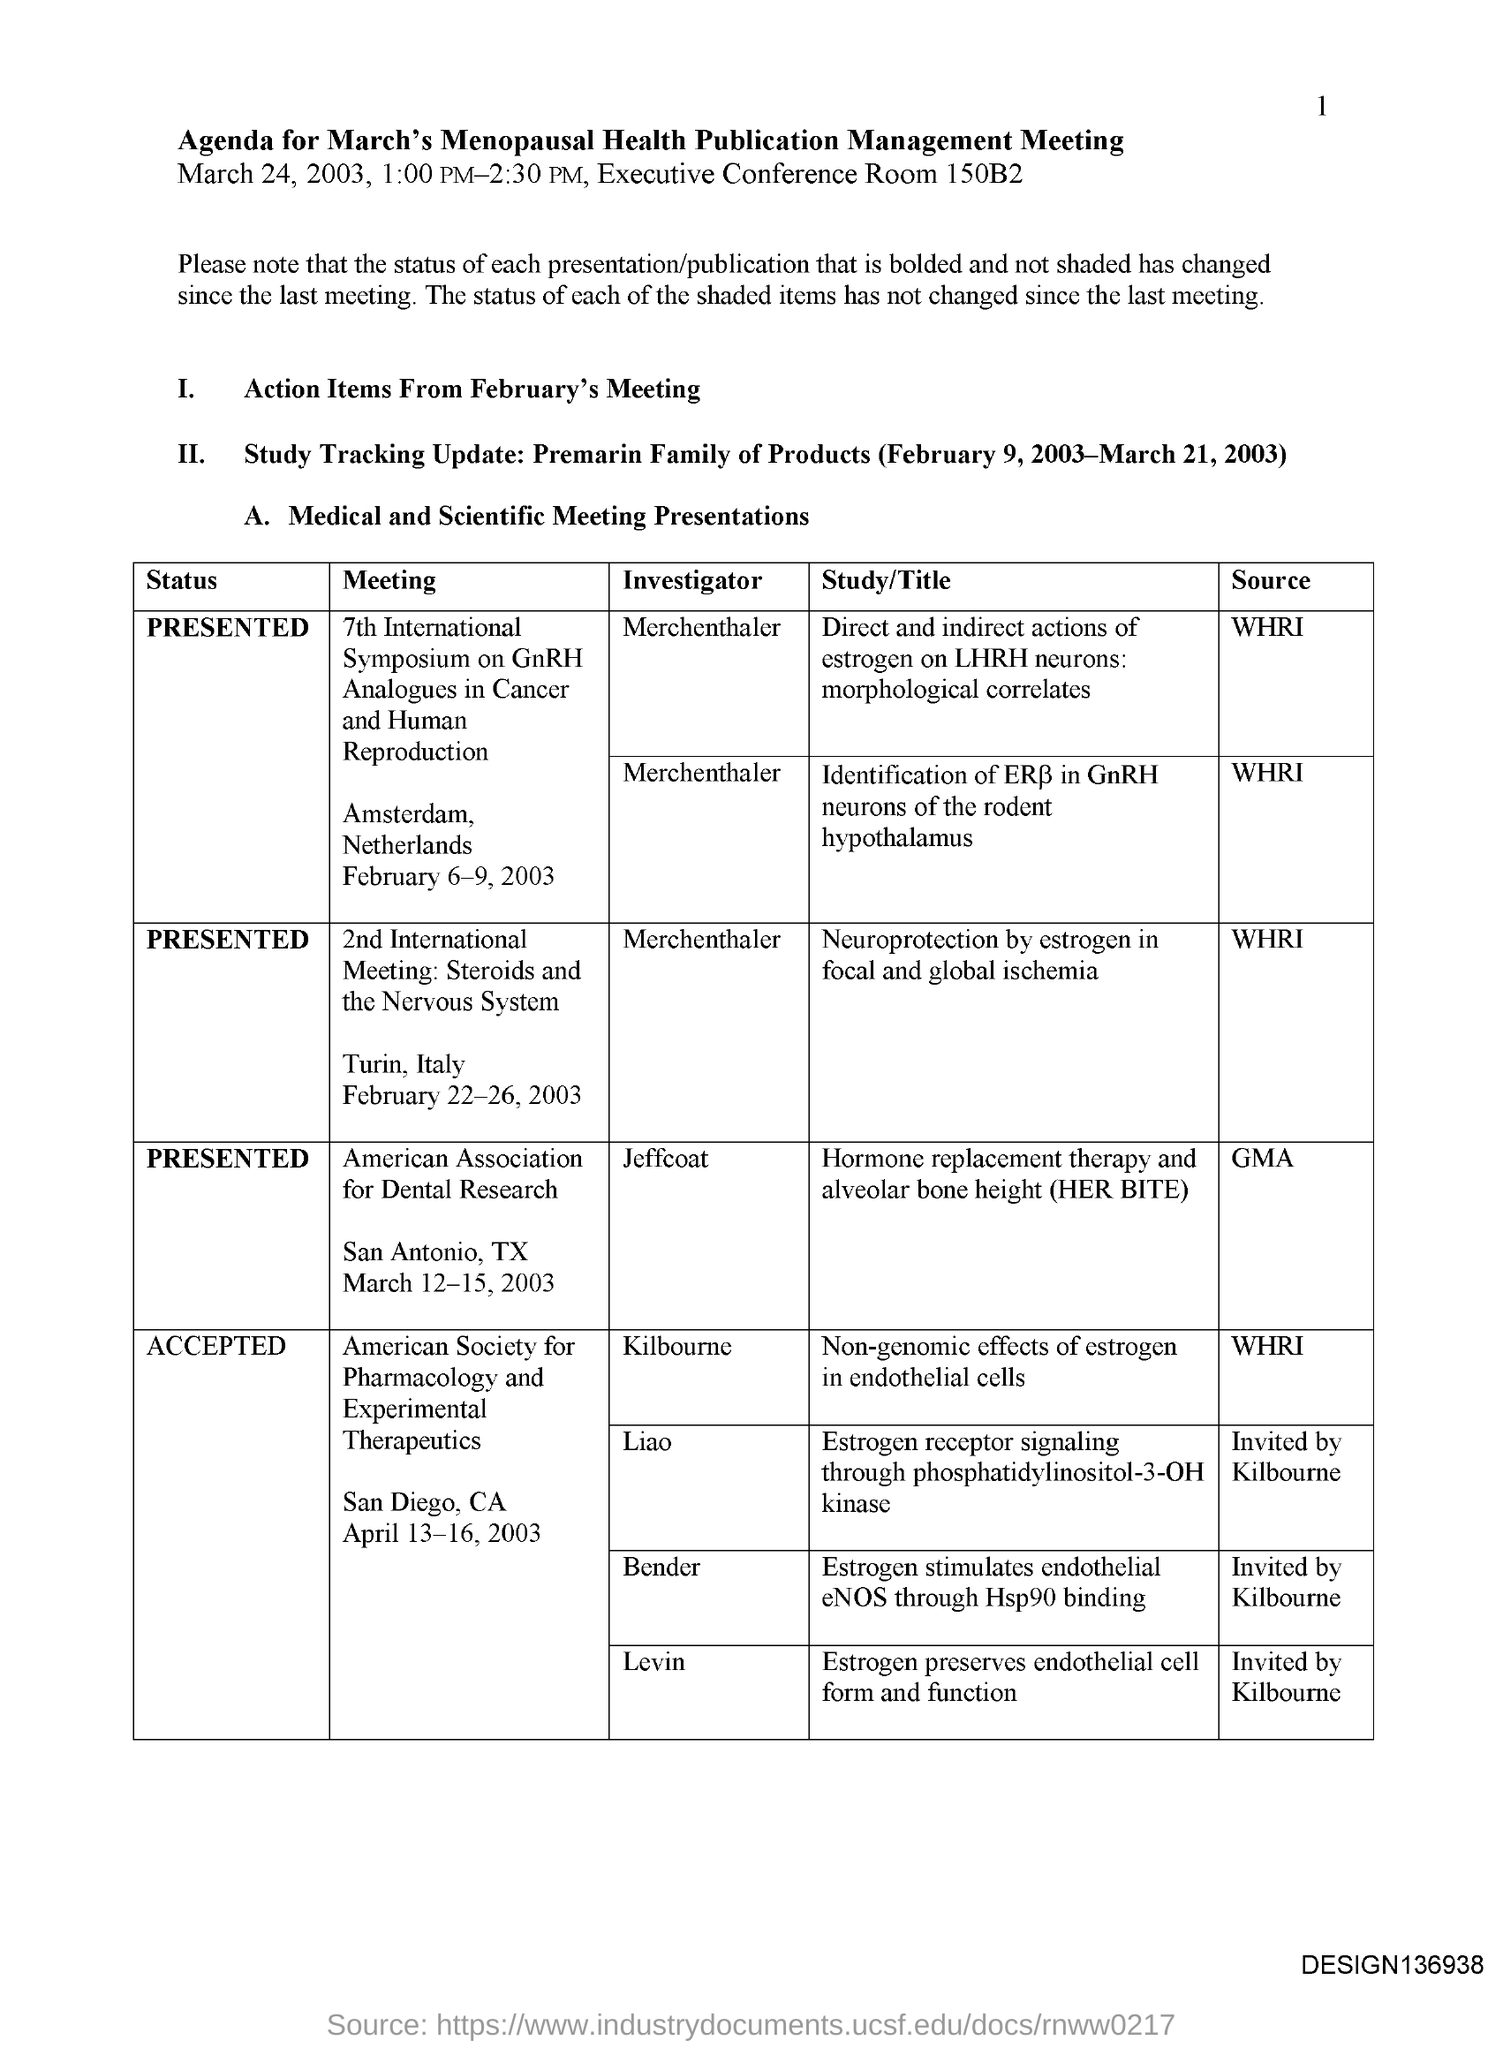What is the title of the document?
Offer a very short reply. Agenda for March's Menopausal health publication management meeting. What is the executive conference room number?
Offer a very short reply. 150B2. 